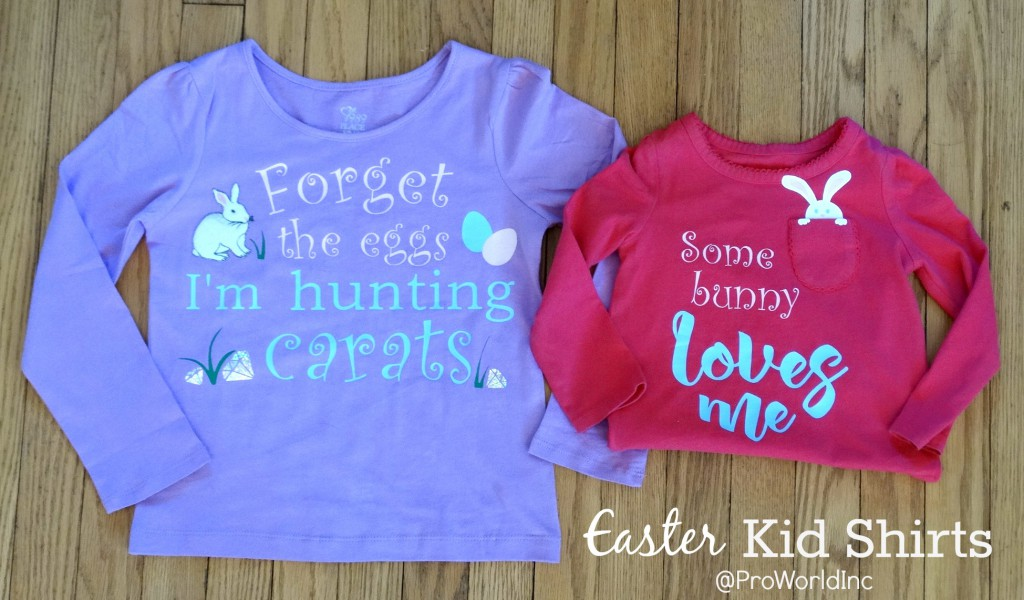What materials are these shirts made of, and are they suitable for sensitive skin? The shirts likely consist of a cotton blend, which is common for children's clothing due to its softness and breathability, making it suitable for sensitive skin. Always check the specific product tags for exact material details and care instructions. 